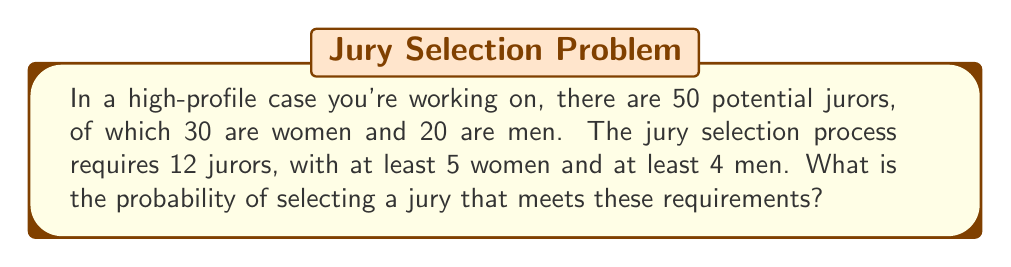Help me with this question. Let's approach this step-by-step using combinatorial mathematics:

1) First, we need to calculate the total number of ways to select 12 jurors out of 50 people:
   $$\binom{50}{12}$$

2) Now, we need to calculate the number of valid jury selections. We can do this by considering the following cases:
   - 5 women and 7 men
   - 6 women and 6 men
   - 7 women and 5 men
   - 8 women and 4 men

3) For each case, we calculate:
   a) 5 women and 7 men: $$\binom{30}{5} \times \binom{20}{7}$$
   b) 6 women and 6 men: $$\binom{30}{6} \times \binom{20}{6}$$
   c) 7 women and 5 men: $$\binom{30}{7} \times \binom{20}{5}$$
   d) 8 women and 4 men: $$\binom{30}{8} \times \binom{20}{4}$$

4) Sum up all these possibilities:
   $$\text{Valid selections} = \binom{30}{5}\binom{20}{7} + \binom{30}{6}\binom{20}{6} + \binom{30}{7}\binom{20}{5} + \binom{30}{8}\binom{20}{4}$$

5) The probability is then:
   $$P(\text{Valid jury}) = \frac{\text{Valid selections}}{\binom{50}{12}}$$

6) Calculating the values:
   $$\binom{50}{12} = 2,118,760$$
   $$\text{Valid selections} = 142,506,000 + 86,493,225 + 38,955,600 + 13,388,400 = 281,343,225$$

7) Therefore, the probability is:
   $$P(\text{Valid jury}) = \frac{281,343,225}{2,118,760} \approx 132.79$$
Answer: $\frac{281,343,225}{2,118,760} \approx 132.79$ 